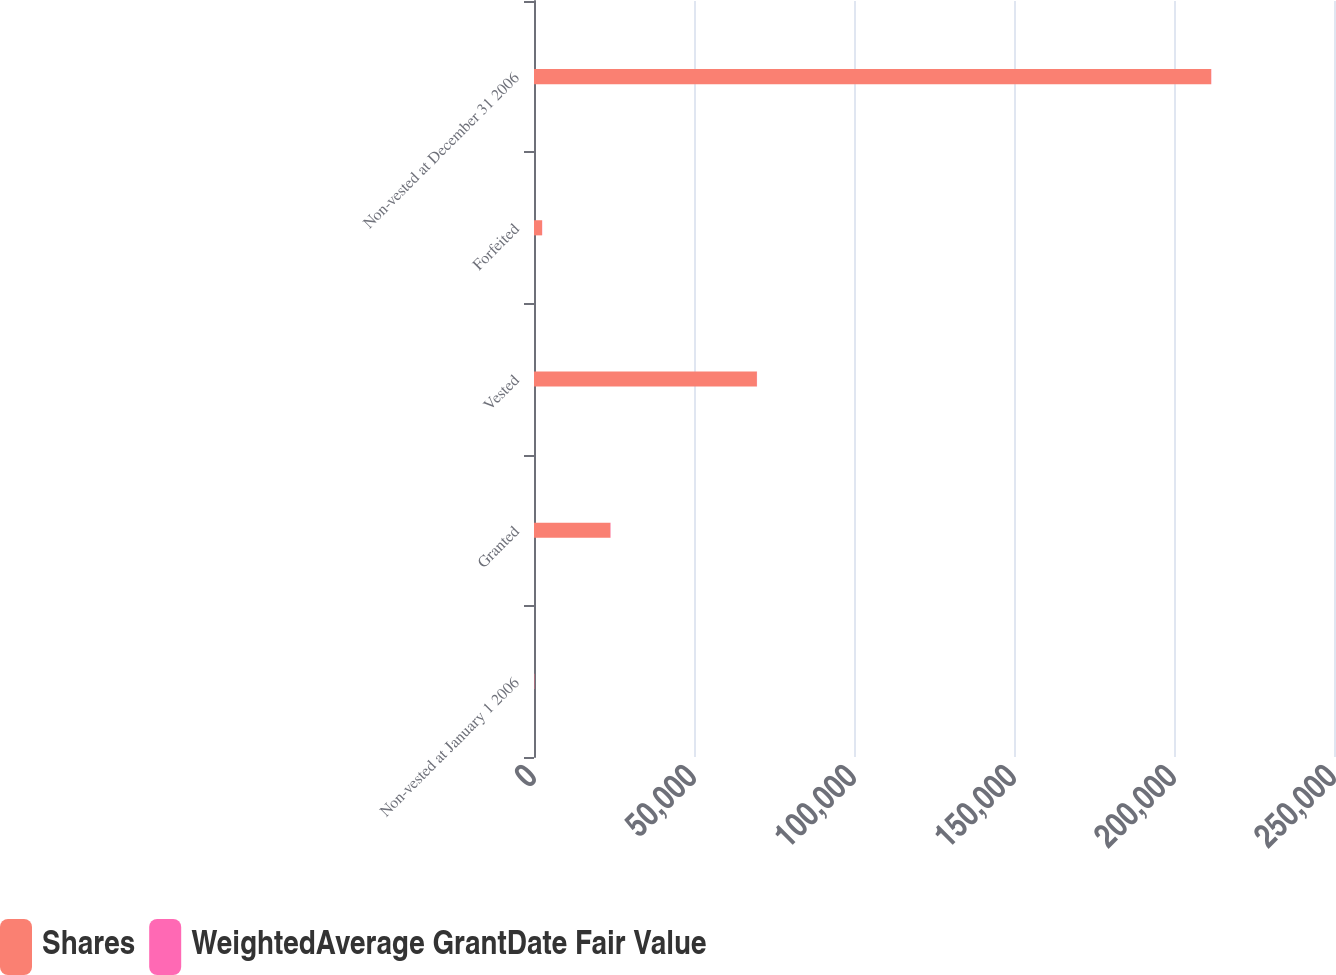<chart> <loc_0><loc_0><loc_500><loc_500><stacked_bar_chart><ecel><fcel>Non-vested at January 1 2006<fcel>Granted<fcel>Vested<fcel>Forfeited<fcel>Non-vested at December 31 2006<nl><fcel>Shares<fcel>88.78<fcel>23854<fcel>69655<fcel>2507<fcel>211605<nl><fcel>WeightedAverage GrantDate Fair Value<fcel>52.27<fcel>88.78<fcel>47.73<fcel>59.88<fcel>57.79<nl></chart> 